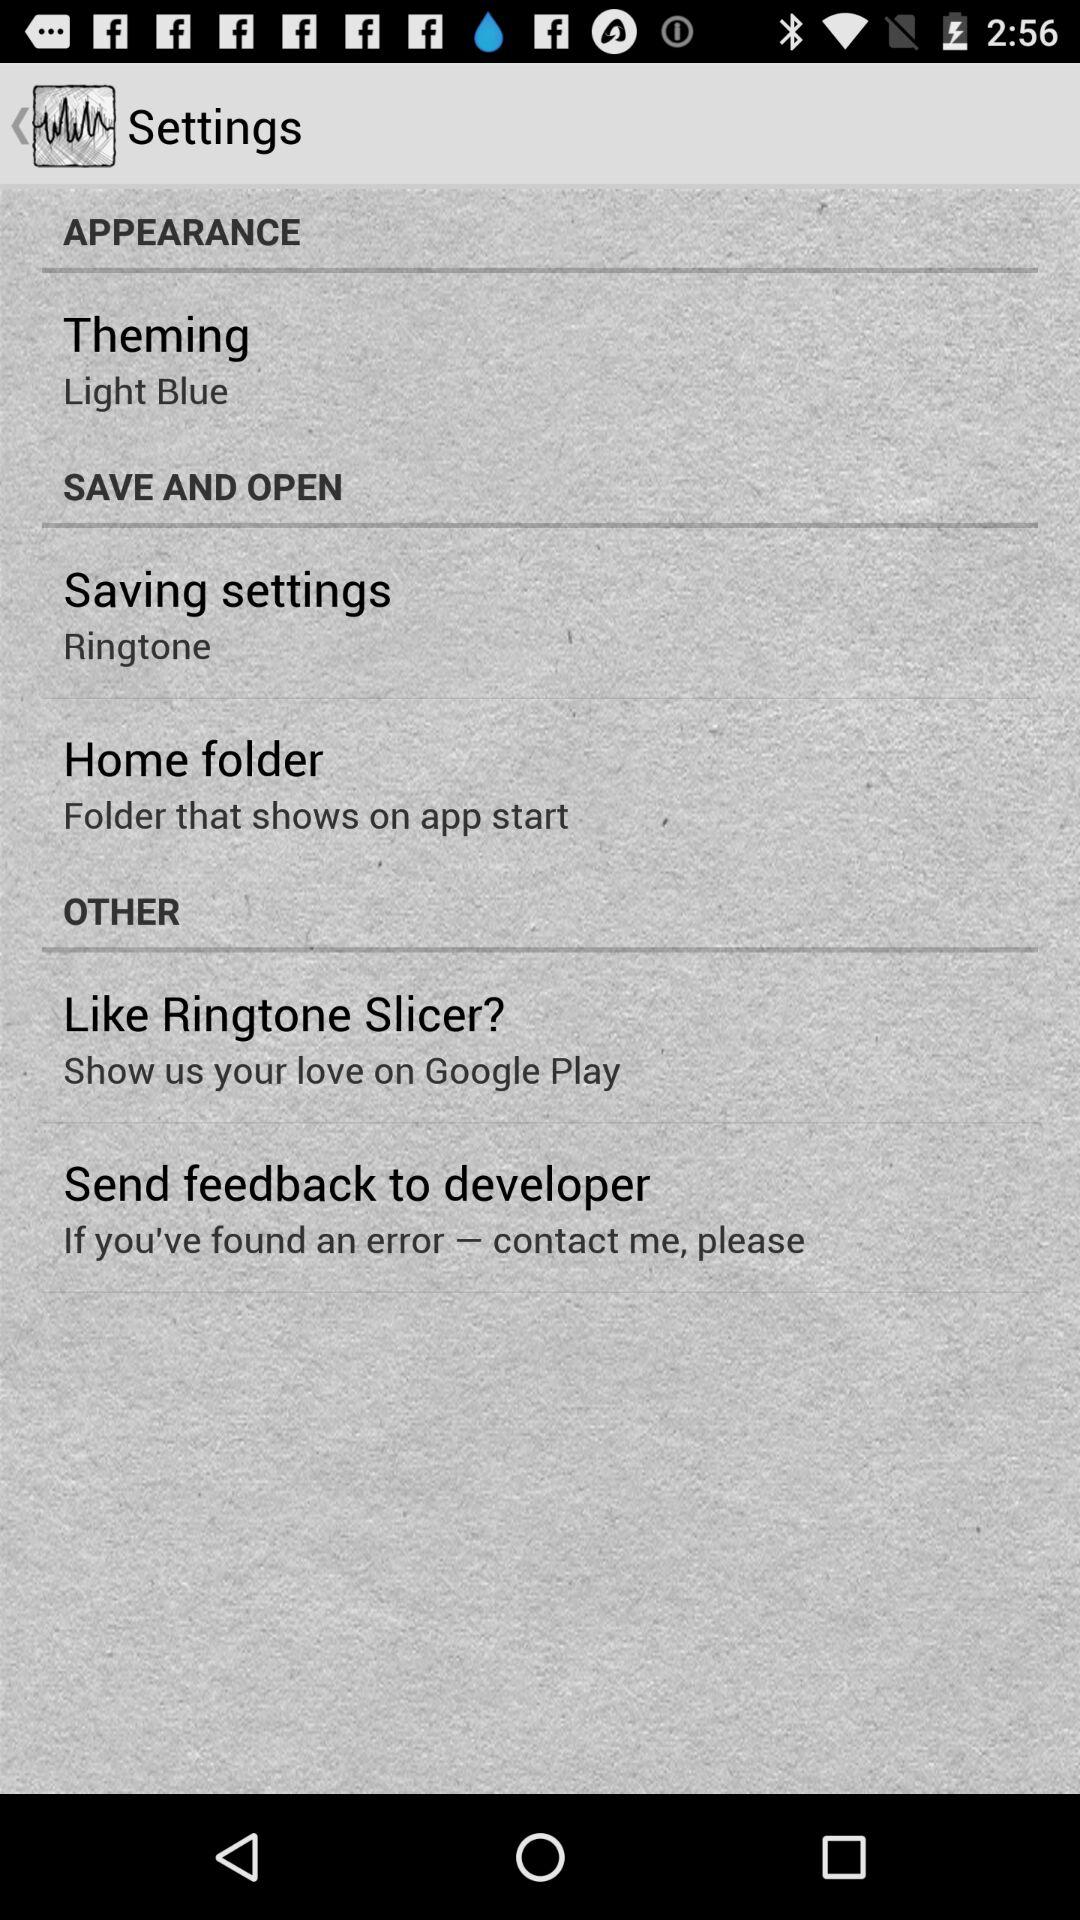What is the theme? The theme is "Light Blue". 